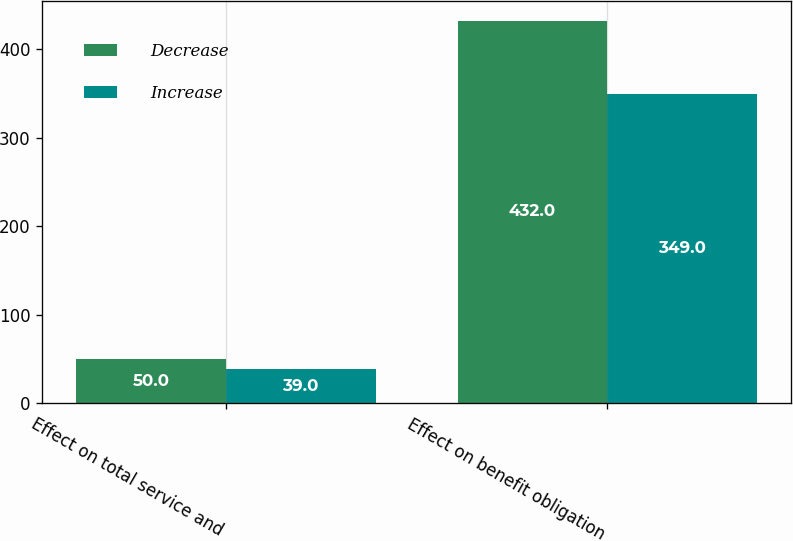Convert chart to OTSL. <chart><loc_0><loc_0><loc_500><loc_500><stacked_bar_chart><ecel><fcel>Effect on total service and<fcel>Effect on benefit obligation<nl><fcel>Decrease<fcel>50<fcel>432<nl><fcel>Increase<fcel>39<fcel>349<nl></chart> 